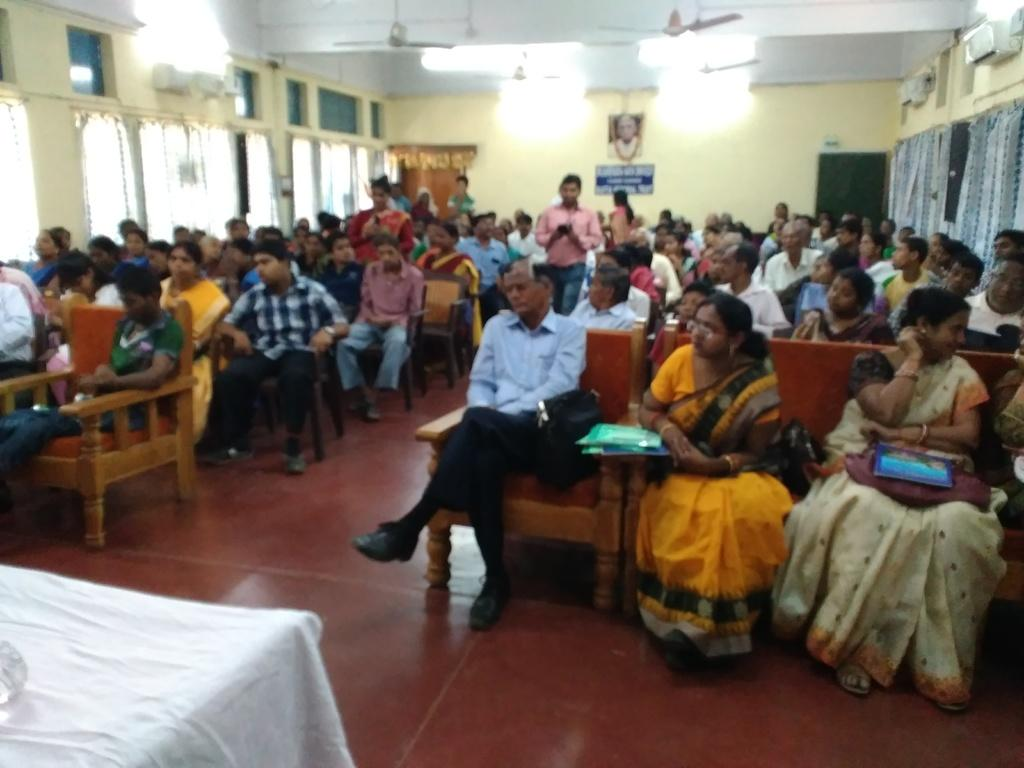What type of structure can be seen in the image? There is a wall in the image. What is hanging on the wall? There is a photo frame in the image. What are the people in the image doing? There are people sitting on chairs in the image. What is located in the front of the image? There is a table in the front of the image. What type of vegetable is being used as a centerpiece on the table in the image? There is no vegetable present on the table in the image. What kind of beast can be seen interacting with the people sitting on chairs? There is no beast present in the image; only people sitting on chairs can be seen. 